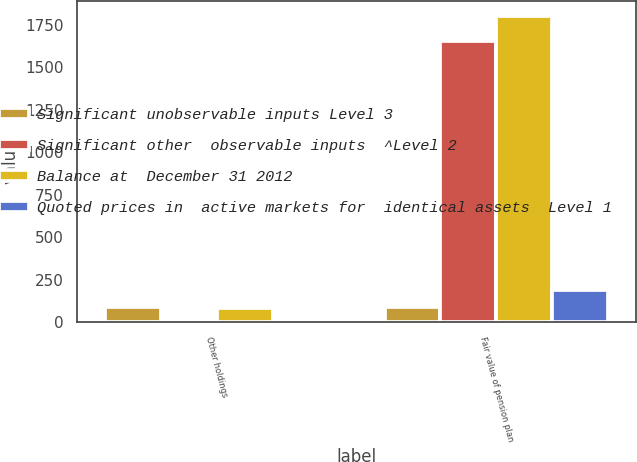Convert chart. <chart><loc_0><loc_0><loc_500><loc_500><stacked_bar_chart><ecel><fcel>Other holdings<fcel>Fair value of pension plan<nl><fcel>Significant unobservable inputs Level 3<fcel>91<fcel>91<nl><fcel>Significant other  observable inputs  ^Level 2<fcel>8<fcel>1655<nl><fcel>Balance at  December 31 2012<fcel>81<fcel>1800<nl><fcel>Quoted prices in  active markets for  identical assets  Level 1<fcel>2<fcel>187<nl></chart> 